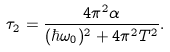Convert formula to latex. <formula><loc_0><loc_0><loc_500><loc_500>\tau _ { 2 } = \frac { 4 \pi ^ { 2 } \alpha } { ( \hbar { \omega } _ { 0 } ) ^ { 2 } + 4 \pi ^ { 2 } T ^ { 2 } } .</formula> 